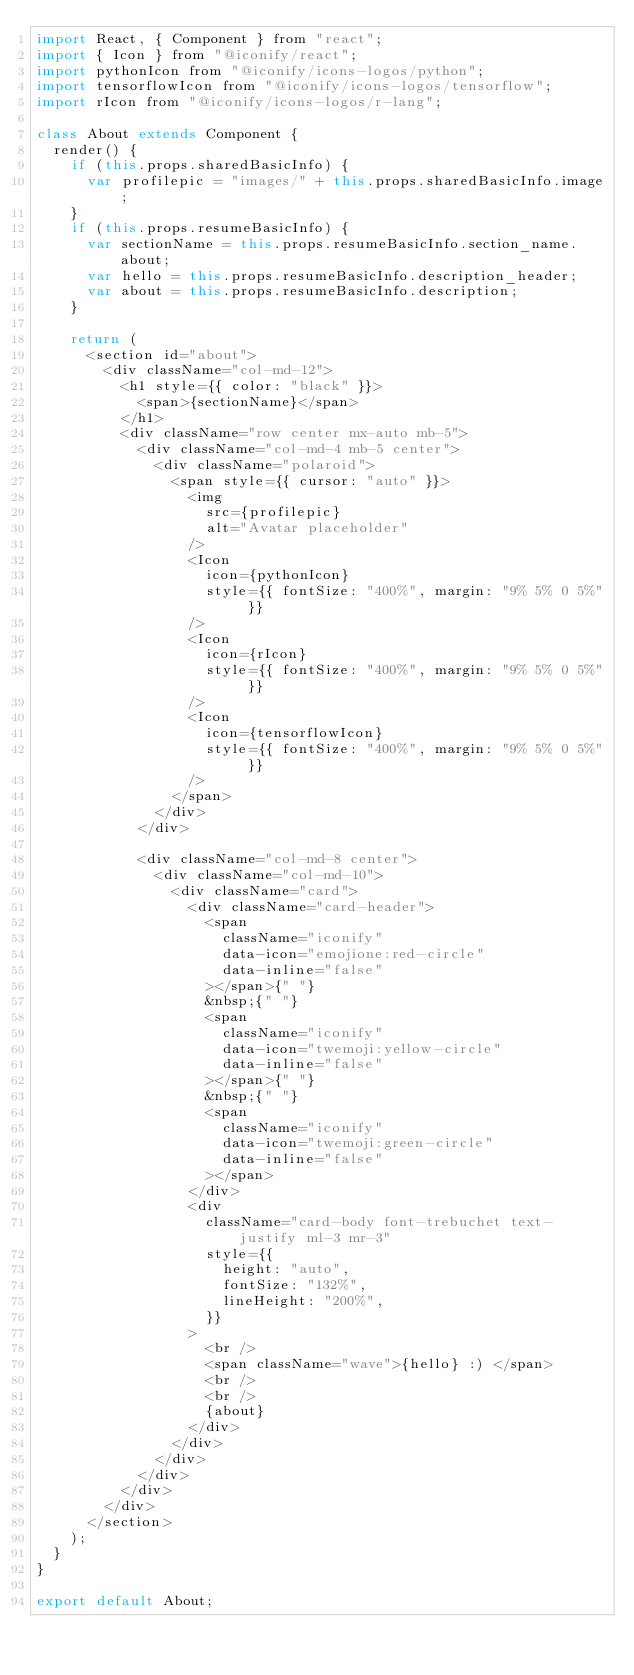<code> <loc_0><loc_0><loc_500><loc_500><_JavaScript_>import React, { Component } from "react";
import { Icon } from "@iconify/react";
import pythonIcon from "@iconify/icons-logos/python";
import tensorflowIcon from "@iconify/icons-logos/tensorflow";
import rIcon from "@iconify/icons-logos/r-lang";

class About extends Component {
  render() {
    if (this.props.sharedBasicInfo) {
      var profilepic = "images/" + this.props.sharedBasicInfo.image;
    }
    if (this.props.resumeBasicInfo) {
      var sectionName = this.props.resumeBasicInfo.section_name.about;
      var hello = this.props.resumeBasicInfo.description_header;
      var about = this.props.resumeBasicInfo.description;
    }

    return (
      <section id="about">
        <div className="col-md-12">
          <h1 style={{ color: "black" }}>
            <span>{sectionName}</span>
          </h1>
          <div className="row center mx-auto mb-5">
            <div className="col-md-4 mb-5 center">
              <div className="polaroid">
                <span style={{ cursor: "auto" }}>
                  <img
                    src={profilepic}
                    alt="Avatar placeholder"
                  />
                  <Icon
                    icon={pythonIcon}
                    style={{ fontSize: "400%", margin: "9% 5% 0 5%" }}
                  />
                  <Icon
                    icon={rIcon}
                    style={{ fontSize: "400%", margin: "9% 5% 0 5%" }}
                  />
                  <Icon
                    icon={tensorflowIcon}
                    style={{ fontSize: "400%", margin: "9% 5% 0 5%" }}
                  />
                </span>
              </div>
            </div>

            <div className="col-md-8 center">
              <div className="col-md-10">
                <div className="card">
                  <div className="card-header">
                    <span
                      className="iconify"
                      data-icon="emojione:red-circle"
                      data-inline="false"
                    ></span>{" "}
                    &nbsp;{" "}
                    <span
                      className="iconify"
                      data-icon="twemoji:yellow-circle"
                      data-inline="false"
                    ></span>{" "}
                    &nbsp;{" "}
                    <span
                      className="iconify"
                      data-icon="twemoji:green-circle"
                      data-inline="false"
                    ></span>
                  </div>
                  <div
                    className="card-body font-trebuchet text-justify ml-3 mr-3"
                    style={{
                      height: "auto",
                      fontSize: "132%",
                      lineHeight: "200%",
                    }}
                  >
                    <br />
                    <span className="wave">{hello} :) </span>
                    <br />
                    <br />
                    {about}
                  </div>
                </div>
              </div>
            </div>
          </div>
        </div>
      </section>
    );
  }
}

export default About;
</code> 